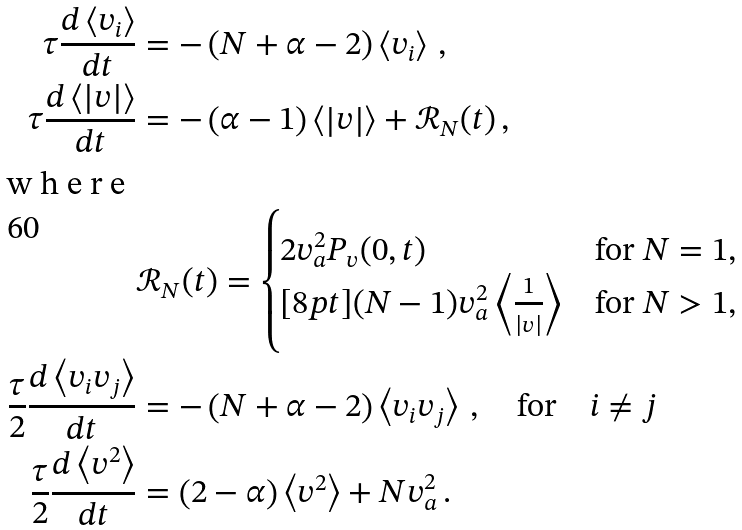<formula> <loc_0><loc_0><loc_500><loc_500>\tau \frac { d \left < v _ { i } \right > } { d t } & = - \left ( N + \alpha - 2 \right ) \left < v _ { i } \right > \, , \\ \tau \frac { d \left < \left | v \right | \right > } { d t } & = - \left ( \alpha - 1 \right ) \left < \left | v \right | \right > + \mathcal { R } _ { N } ( t ) \, , \\ \intertext { w h e r e } & \mathcal { R } _ { N } ( t ) = \begin{cases} 2 v _ { a } ^ { 2 } P _ { v } ( 0 , t ) & \text {for $N=1$,} \\ [ 8 p t ] ( N - 1 ) v _ { a } ^ { 2 } \left < \frac { 1 } { \left | v \right | } \right > & \text {for $N>1$,} \end{cases} \\ \frac { \tau } 2 \frac { d \left < v _ { i } v _ { j } \right > } { d t } & = - \left ( N + \alpha - 2 \right ) \left < v _ { i } v _ { j } \right > \, , \quad \text {for} \quad i \neq j \\ \frac { \tau } 2 \frac { d \left < v ^ { 2 } \right > } { d t } & = \left ( 2 - \alpha \right ) \left < v ^ { 2 } \right > + N v _ { a } ^ { 2 } \, .</formula> 